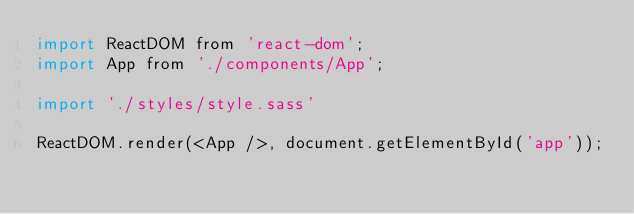Convert code to text. <code><loc_0><loc_0><loc_500><loc_500><_JavaScript_>import ReactDOM from 'react-dom';
import App from './components/App';

import './styles/style.sass'

ReactDOM.render(<App />, document.getElementById('app'));</code> 